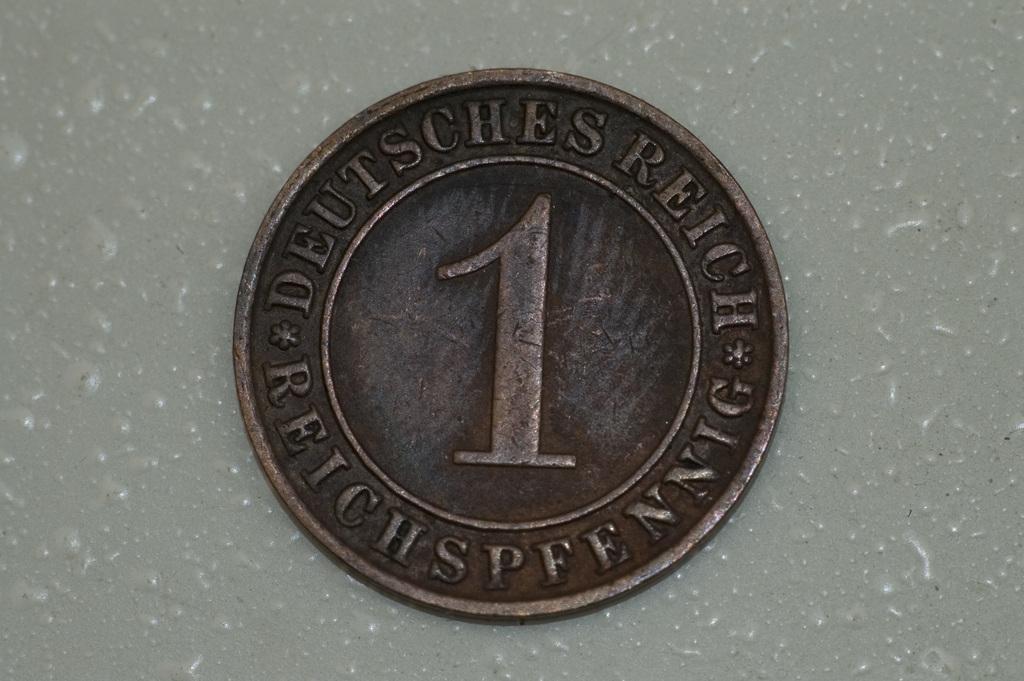What types of coin?
Offer a very short reply. Deutsches reich. 